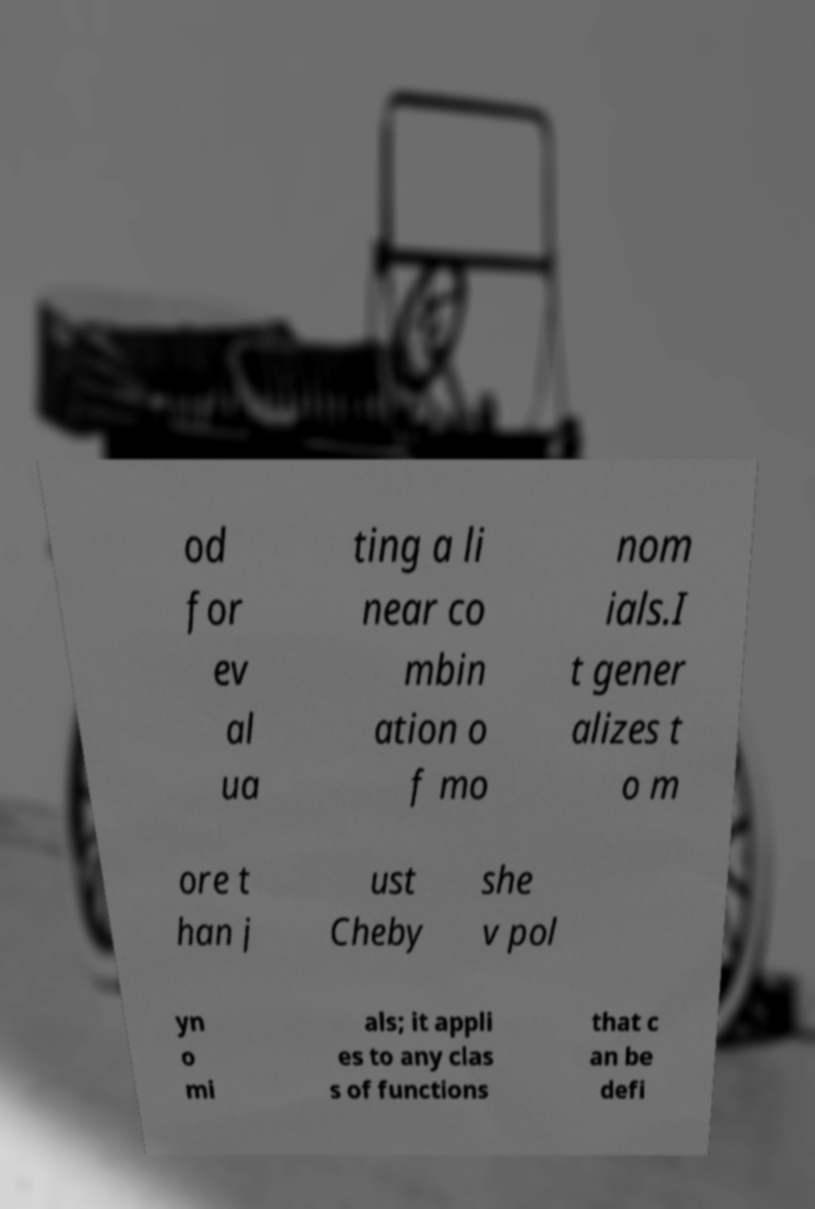For documentation purposes, I need the text within this image transcribed. Could you provide that? od for ev al ua ting a li near co mbin ation o f mo nom ials.I t gener alizes t o m ore t han j ust Cheby she v pol yn o mi als; it appli es to any clas s of functions that c an be defi 